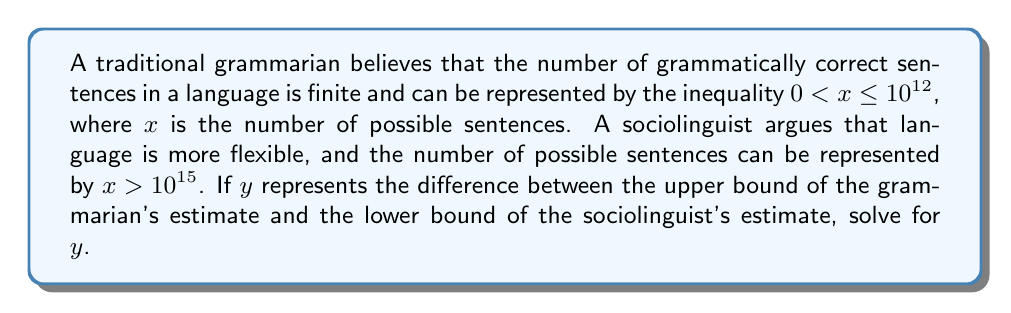Could you help me with this problem? To solve this problem, we need to follow these steps:

1) First, let's identify the upper bound of the grammarian's estimate:
   The inequality $0 < x \leq 10^{12}$ tells us that the upper bound is $10^{12}$.

2) Next, let's identify the lower bound of the sociolinguist's estimate:
   The inequality $x > 10^{15}$ tells us that the lower bound is $10^{15}$.

3) Now, we need to find the difference between these two values:
   $y = 10^{15} - 10^{12}$

4) To subtract these numbers, we need to express them in the same power of 10:
   $y = 1000 \times 10^{12} - 1 \times 10^{12}$

5) Now we can subtract:
   $y = 999 \times 10^{12}$

6) This can be simplified to:
   $y = 9.99 \times 10^{14}$

Therefore, the difference $y$ between the upper bound of the grammarian's estimate and the lower bound of the sociolinguist's estimate is $9.99 \times 10^{14}$.
Answer: $y = 9.99 \times 10^{14}$ 